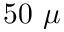Convert formula to latex. <formula><loc_0><loc_0><loc_500><loc_500>5 0 \mu</formula> 